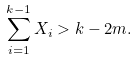<formula> <loc_0><loc_0><loc_500><loc_500>\sum _ { i = 1 } ^ { k - 1 } X _ { i } > k - 2 m .</formula> 